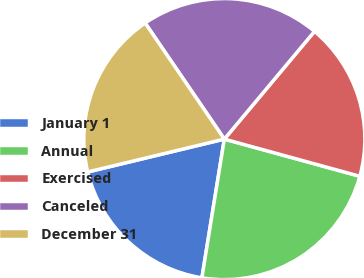Convert chart to OTSL. <chart><loc_0><loc_0><loc_500><loc_500><pie_chart><fcel>January 1<fcel>Annual<fcel>Exercised<fcel>Canceled<fcel>December 31<nl><fcel>18.69%<fcel>23.29%<fcel>18.17%<fcel>20.62%<fcel>19.23%<nl></chart> 